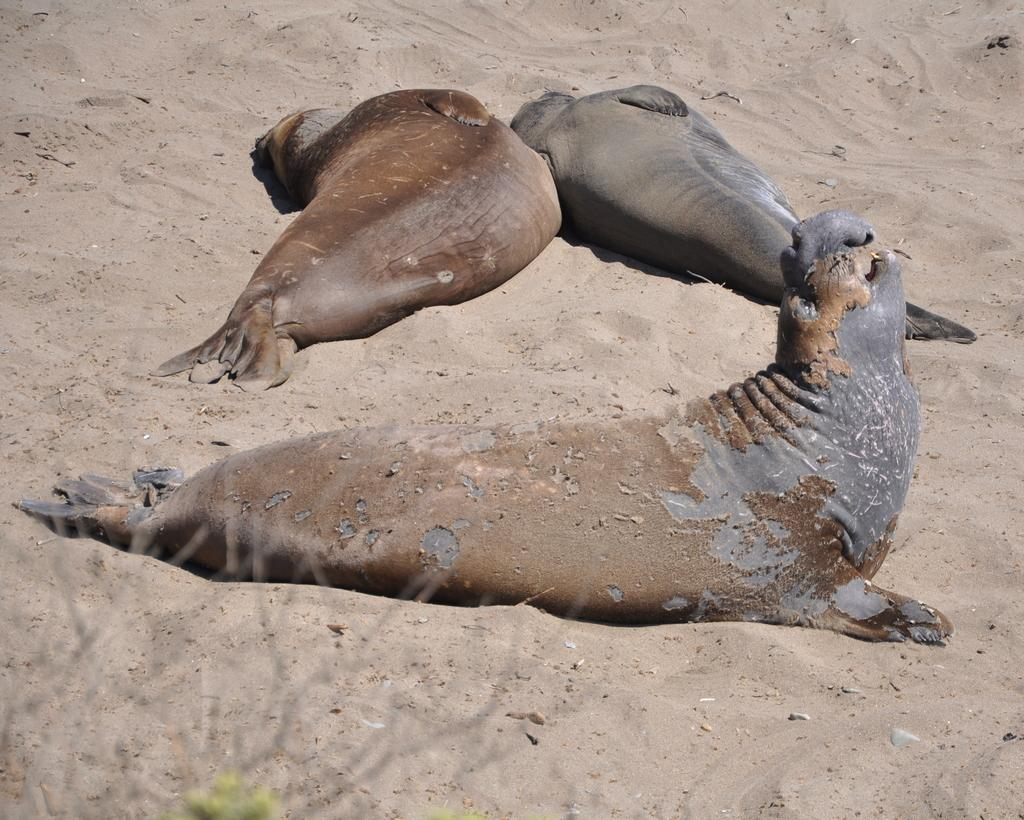How many elephant seals are in the picture? There are three elephant seals in the picture. What can be seen at the bottom of the picture? Plants and sand are visible at the bottom of the picture. What decision does the beggar make in the image? There is no beggar present in the image, so it is not possible to answer that question. 